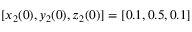<formula> <loc_0><loc_0><loc_500><loc_500>[ x _ { 2 } ( 0 ) , y _ { 2 } ( 0 ) , z _ { 2 } ( 0 ) ] = [ 0 . 1 , 0 . 5 , 0 . 1 ]</formula> 